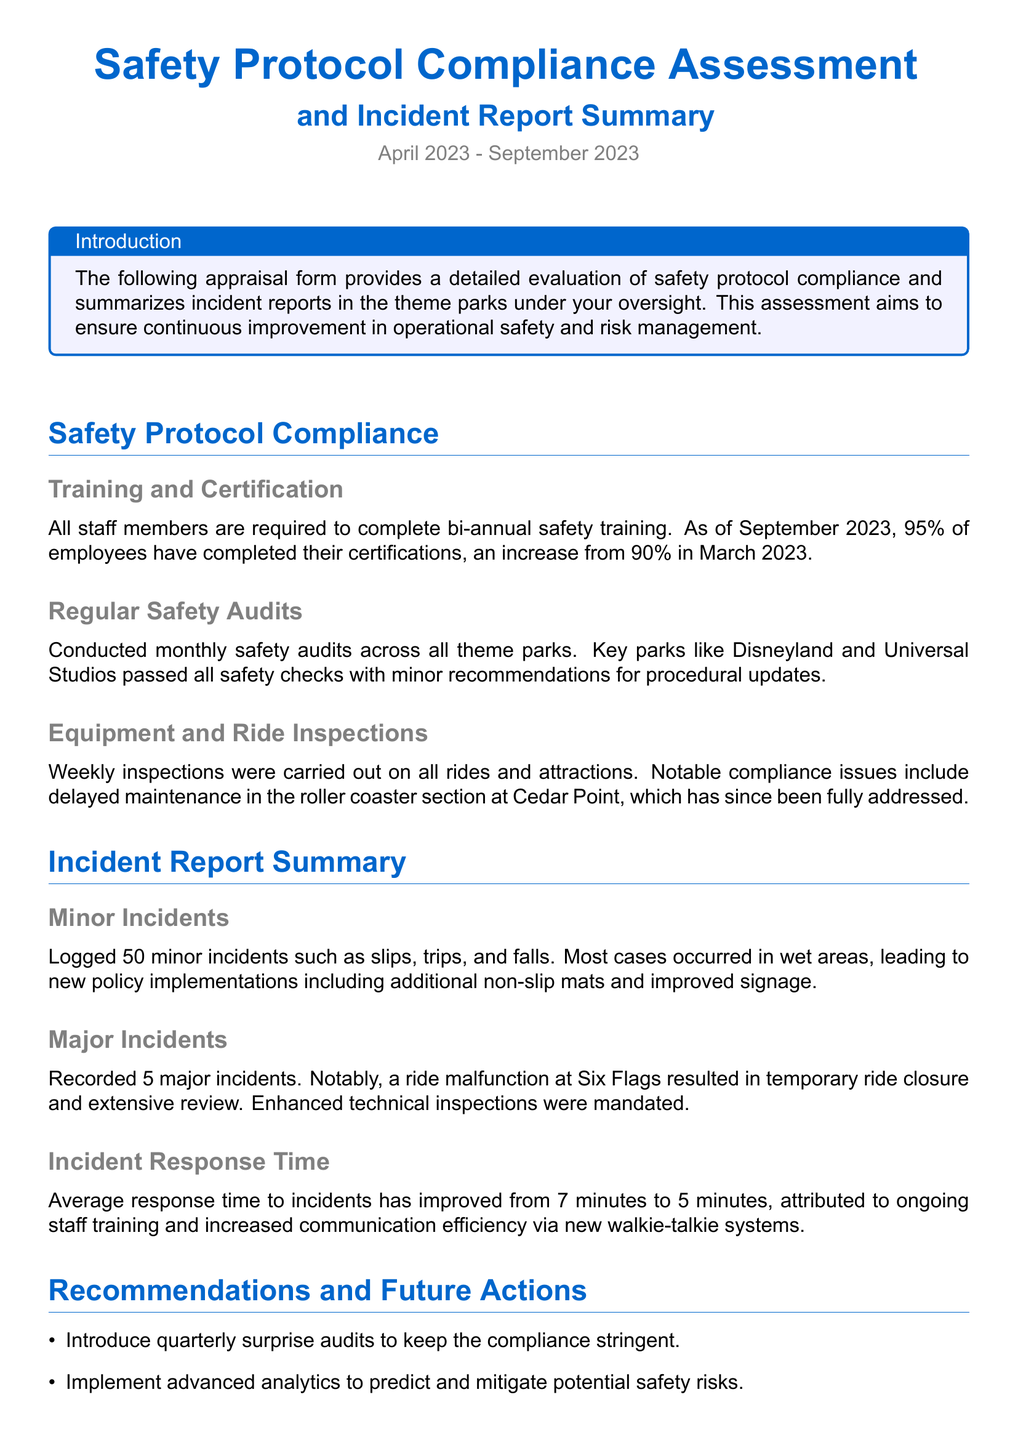What is the completion percentage of employee certifications as of September 2023? The completion percentage of employee certifications as of September 2023 is stated in the document, which is an increase from previous data.
Answer: 95% How many major incidents were recorded? The number of major incidents recorded is explicitly mentioned in the incident report section of the document.
Answer: 5 What recommended action aims to increase compliance? The recommendation that focuses on compliance is mentioned in the section about future actions and is aimed at ensuring thorough oversight.
Answer: Quarterly surprise audits What is the average incident response time improvement? The document specifies the average response time improvement, which highlights the effectiveness of recent changes in procedures.
Answer: 2 minutes Which park had notable compliance issues with delayed maintenance? The name of the park with compliance issues is detailed under equipment and ride inspections in the document.
Answer: Cedar Point How many minor incidents were logged? The total number of minor incidents logged is clearly stated in the summary section of the document.
Answer: 50 What percentage of employees completed safety training in March 2023? The previous percentage of employees who completed their training in March 2023 is included to illustrate progress over time.
Answer: 90% What is the main purpose of the assessment provided in the document? The purpose of the assessment is mentioned in the introduction, focusing on improving operational safety and risk management.
Answer: Continuous improvement What type of incidents were primarily addressed by new policy implementations? The specific type of incidents that led to new policy changes are described in the minor incident section.
Answer: Slips, trips, and falls 